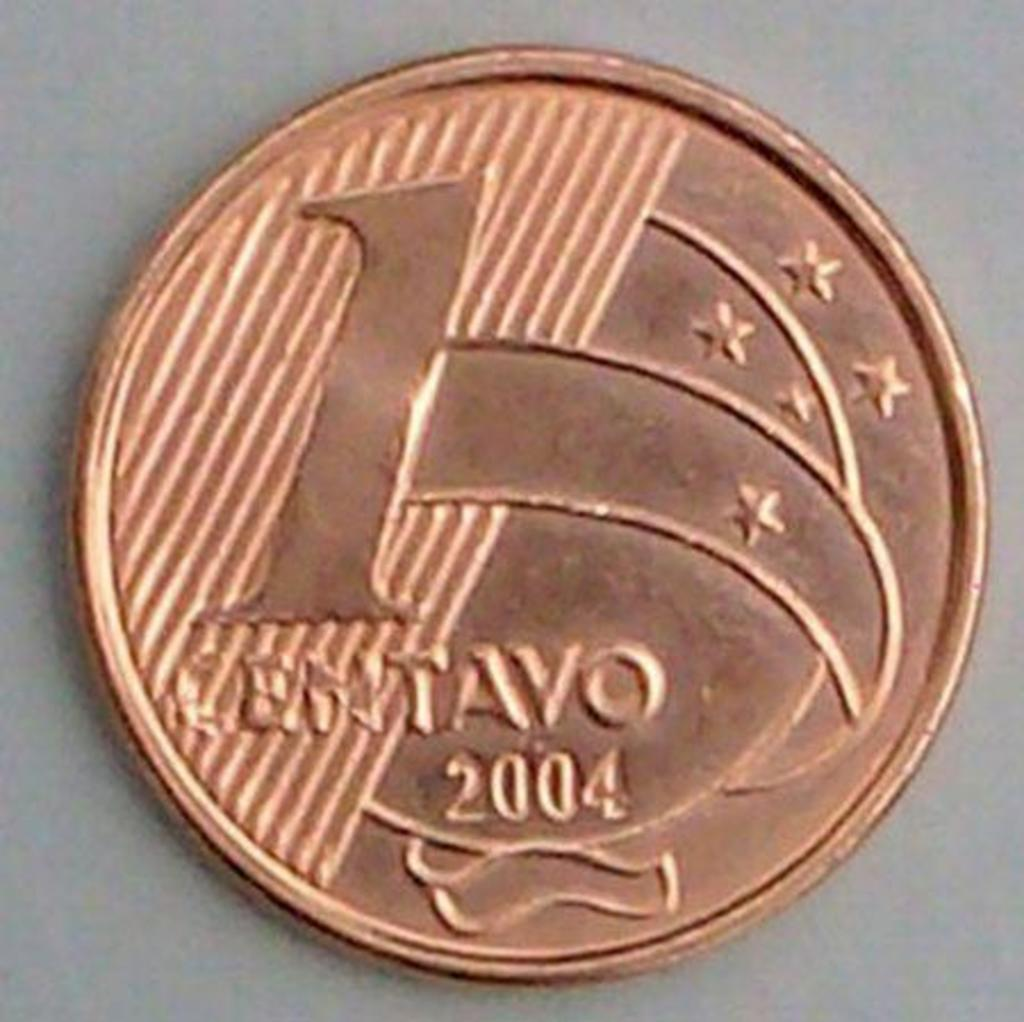<image>
Give a short and clear explanation of the subsequent image. a golden coin that says 'entavo 2004' on it 